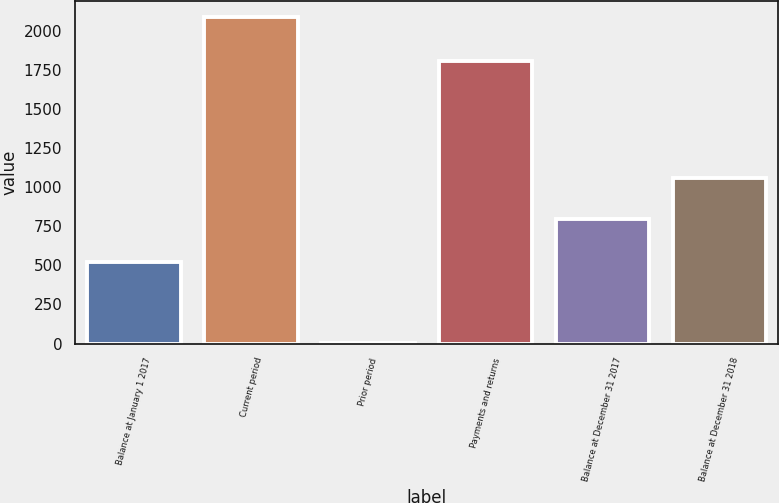<chart> <loc_0><loc_0><loc_500><loc_500><bar_chart><fcel>Balance at January 1 2017<fcel>Current period<fcel>Prior period<fcel>Payments and returns<fcel>Balance at December 31 2017<fcel>Balance at December 31 2018<nl><fcel>520<fcel>2090<fcel>4<fcel>1810<fcel>796<fcel>1061<nl></chart> 